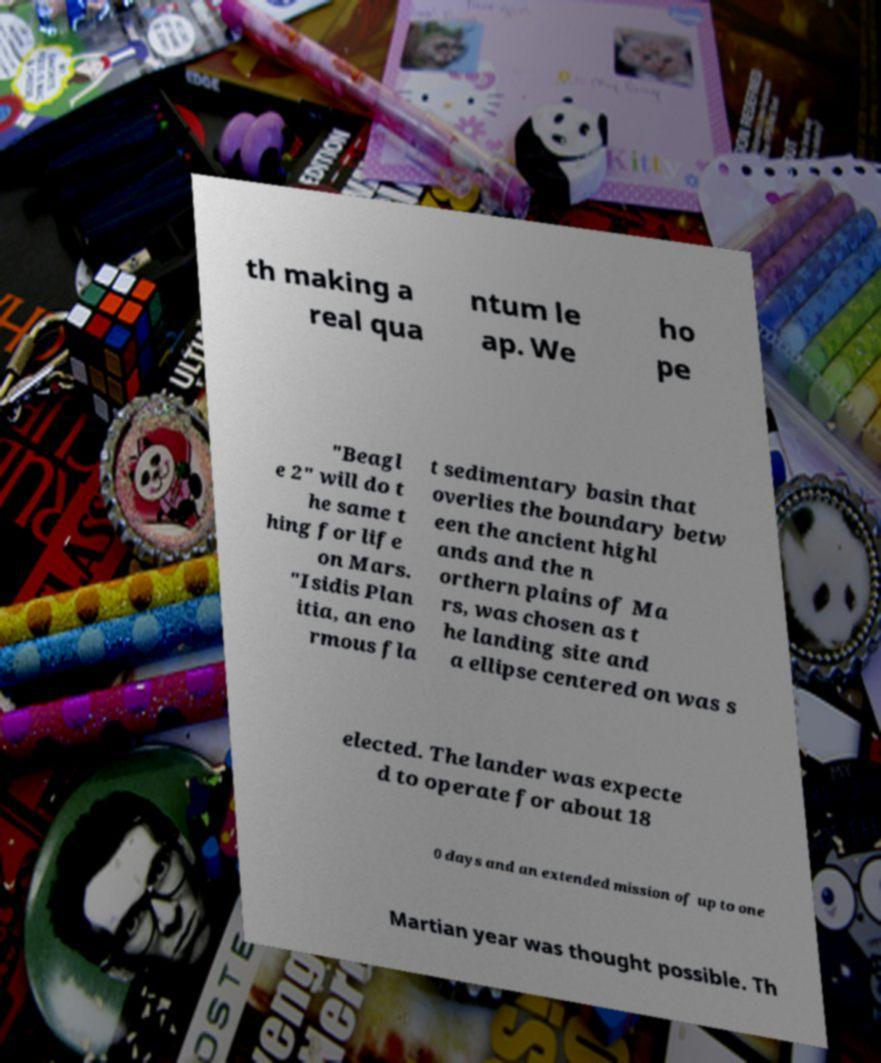There's text embedded in this image that I need extracted. Can you transcribe it verbatim? th making a real qua ntum le ap. We ho pe "Beagl e 2" will do t he same t hing for life on Mars. "Isidis Plan itia, an eno rmous fla t sedimentary basin that overlies the boundary betw een the ancient highl ands and the n orthern plains of Ma rs, was chosen as t he landing site and a ellipse centered on was s elected. The lander was expecte d to operate for about 18 0 days and an extended mission of up to one Martian year was thought possible. Th 